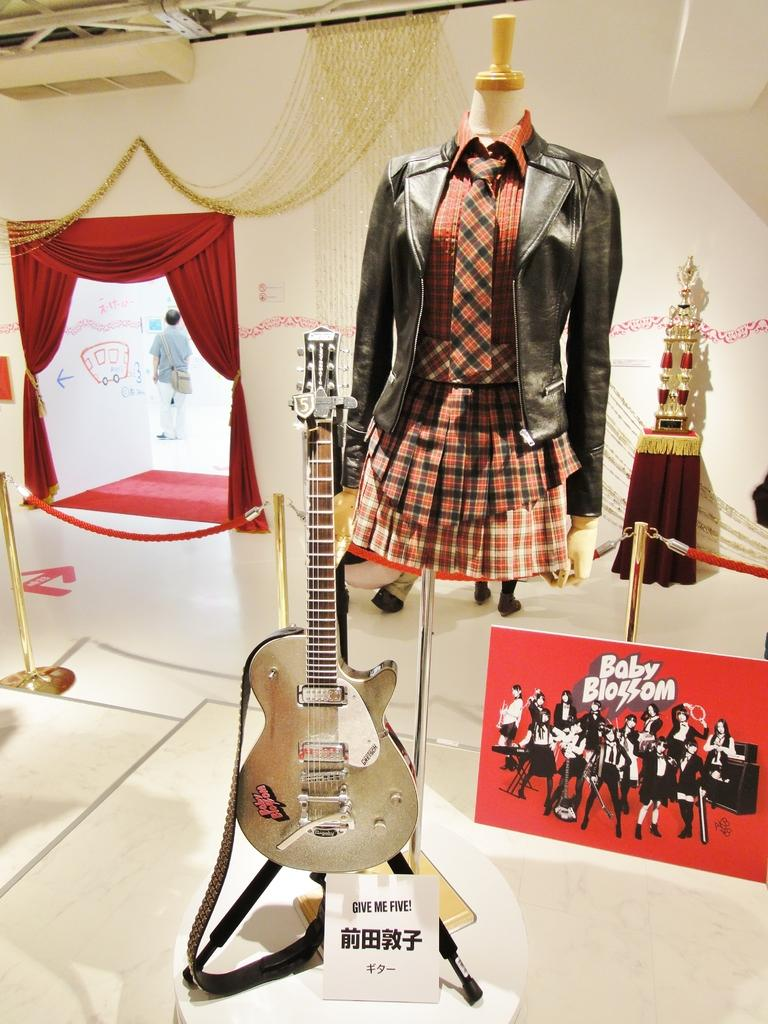What type of clothing is featured in the image? There is a black and red dress in the image. Who does the dress belong to? The dress belongs to a woman. What other item is visible near the dress? There is a guitar beside the dress. Can you describe the background of the image? There are other objects in the background of the image. How many vases are present on the guitar in the image? There are no vases present on the guitar in the image. What type of metal is the dress made of in the image? The dress is made of fabric, not metal, and there is no mention of zinc in the image. 